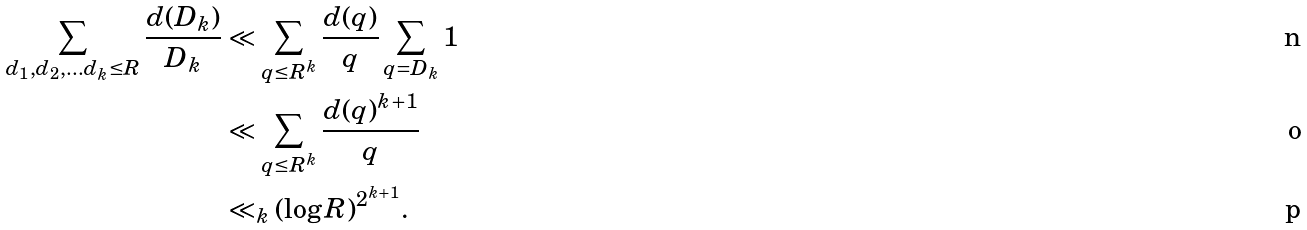<formula> <loc_0><loc_0><loc_500><loc_500>\sum _ { d _ { 1 } , d _ { 2 } , \dots d _ { k } \leq R } \frac { d ( D _ { k } ) } { D _ { k } } & \ll \sum _ { q \leq R ^ { k } } \frac { d ( q ) } { q } \sum _ { q = D _ { k } } 1 \\ & \ll \sum _ { q \leq R ^ { k } } \frac { d ( q ) ^ { k + 1 } } { q } \\ & \ll _ { k } ( \log R ) ^ { 2 ^ { k + 1 } } .</formula> 